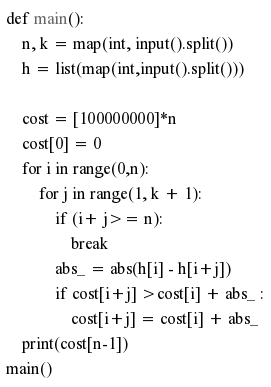Convert code to text. <code><loc_0><loc_0><loc_500><loc_500><_Python_>def main():
    n, k = map(int, input().split())
    h = list(map(int,input().split()))

    cost = [100000000]*n
    cost[0] = 0
    for i in range(0,n):
        for j in range(1, k + 1):
            if (i+ j>= n):
                break
            abs_ = abs(h[i] - h[i+j])
            if cost[i+j] >cost[i] + abs_ :
                cost[i+j] = cost[i] + abs_
    print(cost[n-1])
main()
</code> 